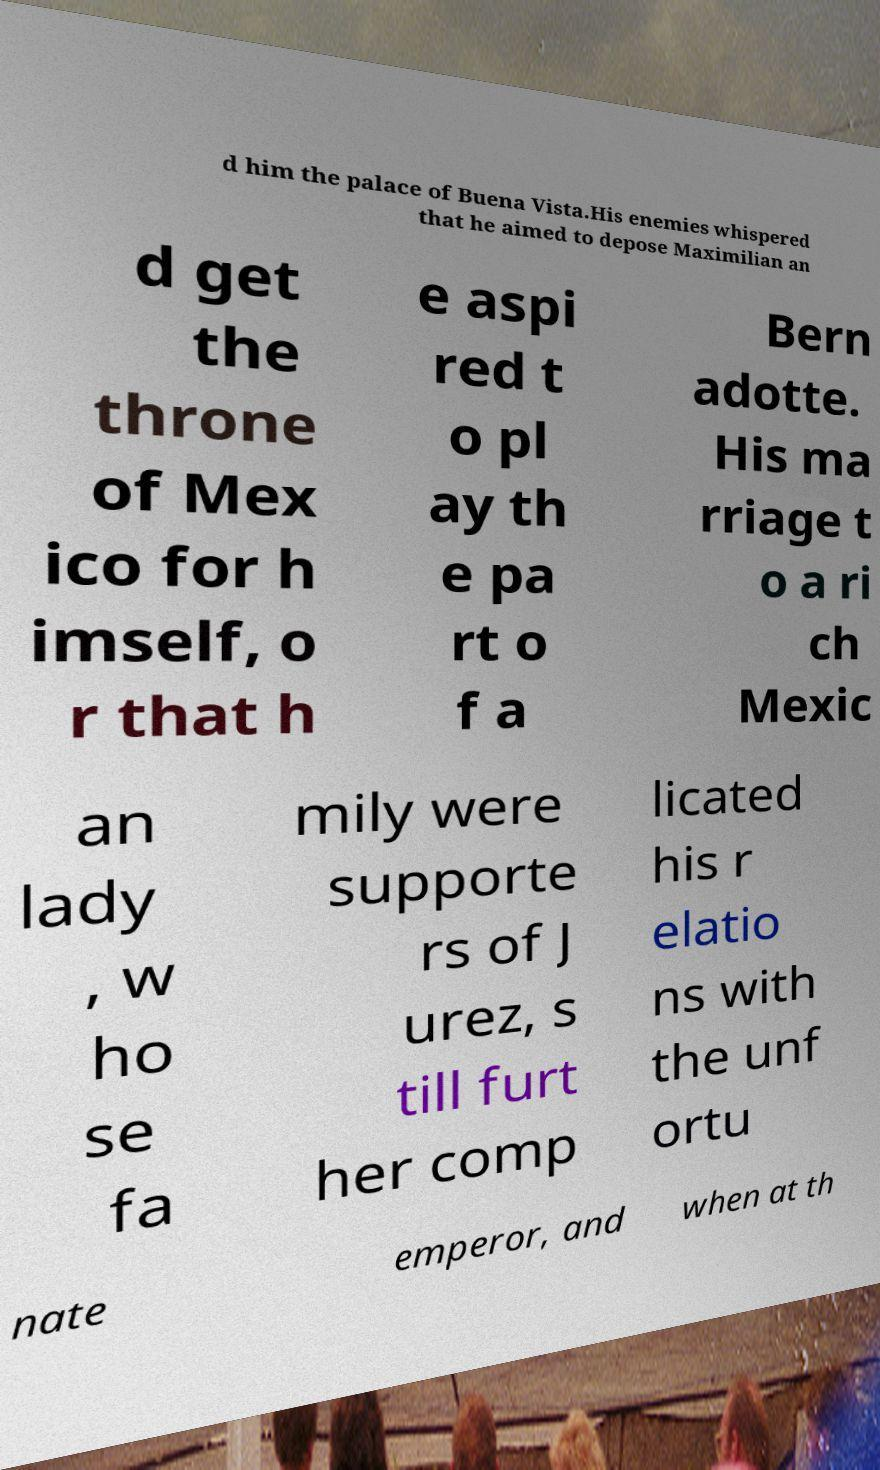I need the written content from this picture converted into text. Can you do that? d him the palace of Buena Vista.His enemies whispered that he aimed to depose Maximilian an d get the throne of Mex ico for h imself, o r that h e aspi red t o pl ay th e pa rt o f a Bern adotte. His ma rriage t o a ri ch Mexic an lady , w ho se fa mily were supporte rs of J urez, s till furt her comp licated his r elatio ns with the unf ortu nate emperor, and when at th 